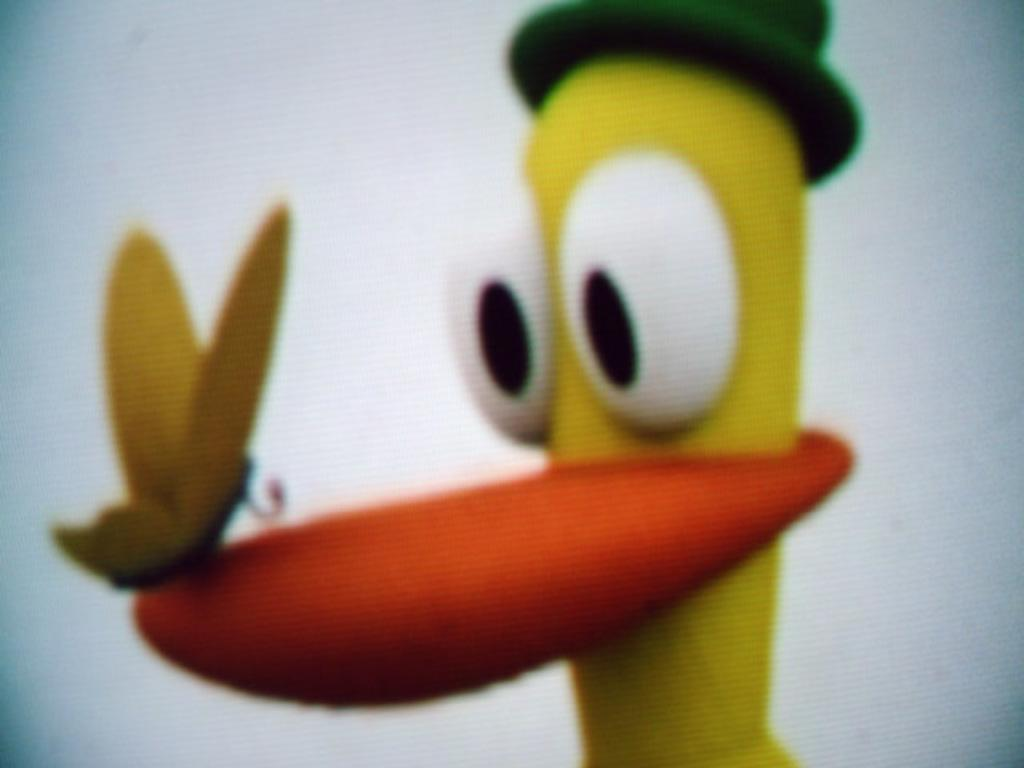What type of content is depicted in the image? There is a cartoon in the image. Are there any living creatures in the image? Yes, there is a butterfly in the image. What color is the background of the image? The background of the image is white. How many squares can be seen in the image? There are no squares present in the image. What time does the clock show in the image? There is no clock present in the image. 